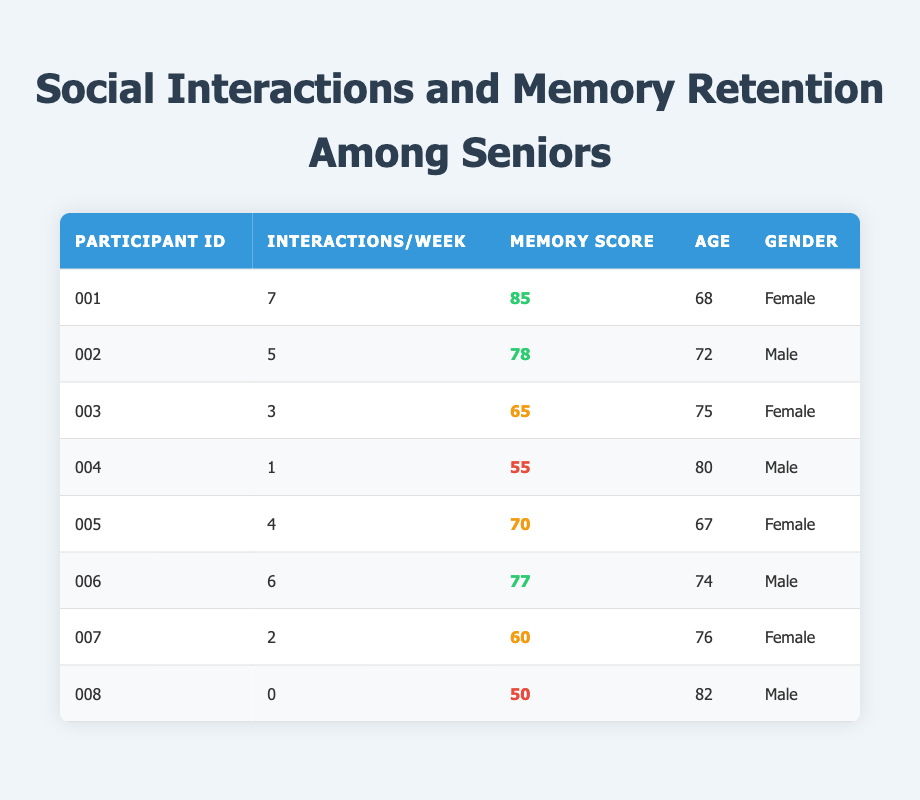What is the memory retention score of the participant with the highest frequency of interactions? Looking at the table, participant ID 001 has the highest frequency of interactions with a value of 7. The corresponding memory retention score for participant ID 001 is 85.
Answer: 85 How many participants have a memory retention score below 60? By examining the table, participants with scores below 60 are participant IDs 004 and 008. This gives a total of 2 participants.
Answer: 2 What is the average frequency of interactions per week across all participants? To calculate the average, I sum the frequency values: 7 + 5 + 3 + 1 + 4 + 6 + 2 + 0 = 28. There are 8 participants, so the average is 28 divided by 8, which equals 3.5.
Answer: 3.5 Which gender has a higher average memory retention score? The memory retention scores of females are 85, 65, 70, and 60, giving a total of 280. For males, the scores are 78, 55, 77, and 50, totaling 260. The average for females is 280/4 = 70, while for males it is 260/4 = 65. Thus, females have a higher average.
Answer: Female Is it true that all participants with 5 or more interactions have memory scores above 75? The table shows that participants with 5 or more interactions are IDs 001 (85), 002 (78), 006 (77), and these scores are indeed above 75.
Answer: Yes What is the difference between the highest and lowest memory retention scores? The highest score is from participant ID 001, which is 85, and the lowest score comes from participant ID 008, which is 50. The difference is 85 - 50 = 35.
Answer: 35 How many participants aged over 75 score above 60 in memory retention? Participants aged over 75 are IDs 003 (75), 004 (80), 006 (74), and 008 (82). Only IDs 003 (65) and 007 (60) exceed 60, so two participants fulfill this criterion.
Answer: 2 If we rank the participants by their memory scores, who holds the third position? The memory scores in descending order are: 85 (ID 001), 78 (ID 002), 77 (ID 006), and 70 (ID 005). The third highest is ID 006 with a score of 77.
Answer: 006 